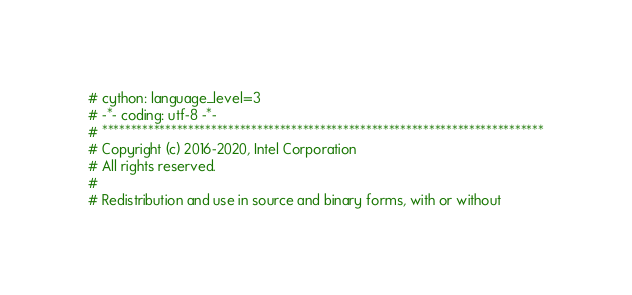<code> <loc_0><loc_0><loc_500><loc_500><_Cython_># cython: language_level=3
# -*- coding: utf-8 -*-
# *****************************************************************************
# Copyright (c) 2016-2020, Intel Corporation
# All rights reserved.
#
# Redistribution and use in source and binary forms, with or without</code> 